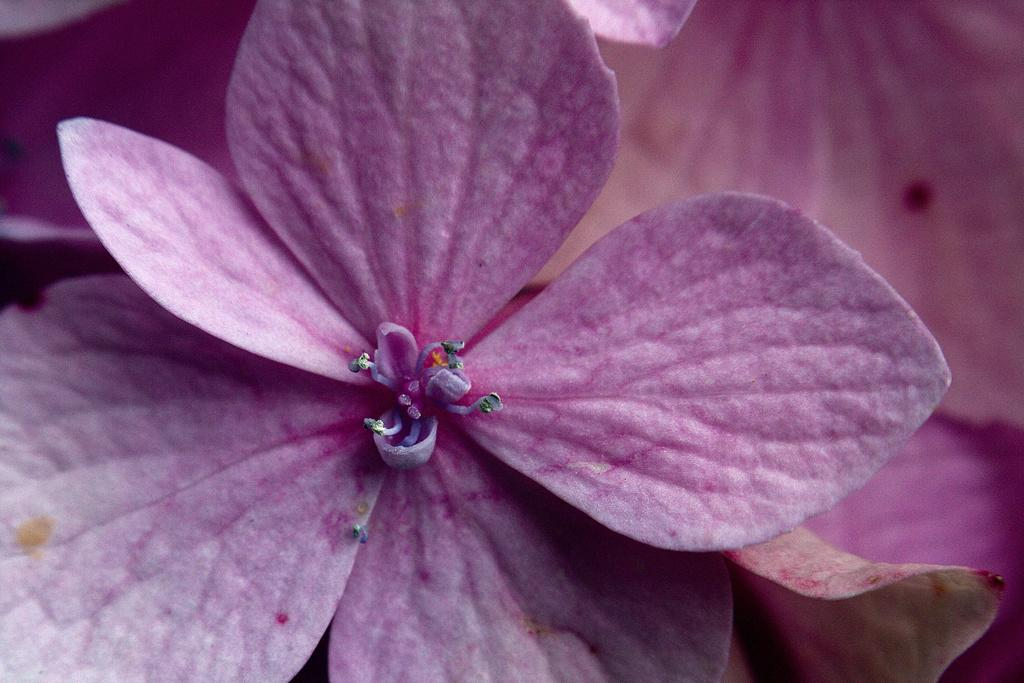What type of plants can be seen in the image? There are flowers in the image. What color are the flowers? The flowers are purple in color. What part of the flowers is visible in the image? The petals of the flowers are visible. Are there any cobwebs visible in the image? There is no mention of cobwebs in the provided facts, and therefore we cannot determine if any are present in the image. 